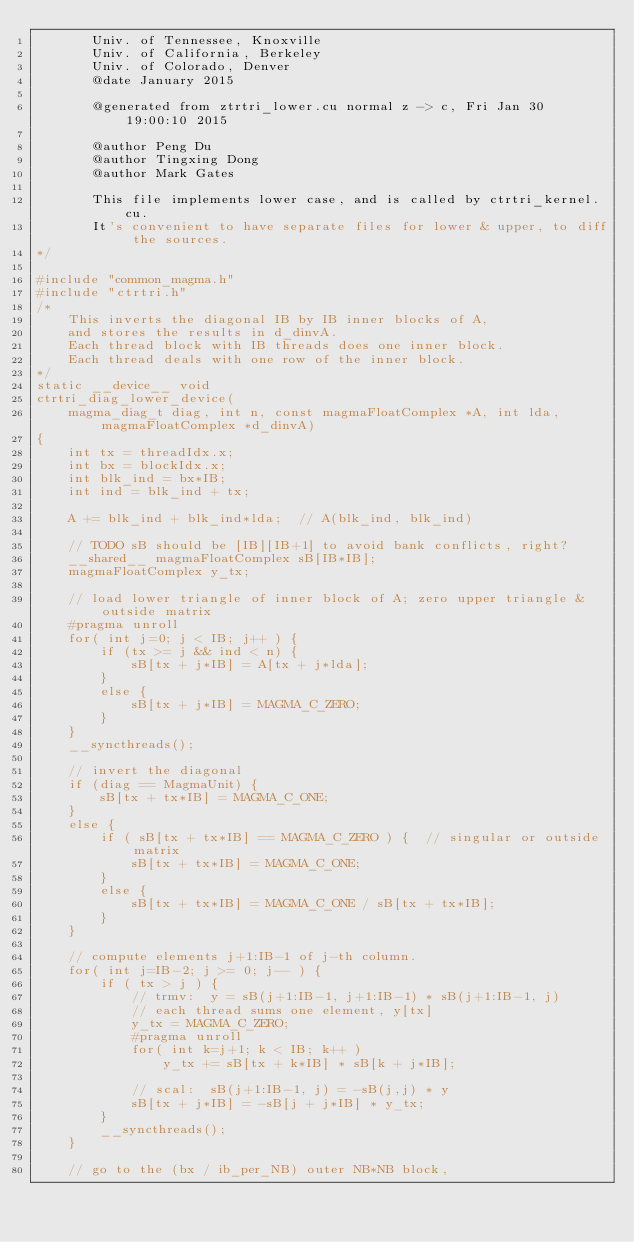Convert code to text. <code><loc_0><loc_0><loc_500><loc_500><_Cuda_>       Univ. of Tennessee, Knoxville
       Univ. of California, Berkeley
       Univ. of Colorado, Denver
       @date January 2015

       @generated from ztrtri_lower.cu normal z -> c, Fri Jan 30 19:00:10 2015

       @author Peng Du
       @author Tingxing Dong
       @author Mark Gates
       
       This file implements lower case, and is called by ctrtri_kernel.cu.
       It's convenient to have separate files for lower & upper, to diff the sources.
*/

#include "common_magma.h"
#include "ctrtri.h"
/*
    This inverts the diagonal IB by IB inner blocks of A,
    and stores the results in d_dinvA.
    Each thread block with IB threads does one inner block.
    Each thread deals with one row of the inner block.
*/
static __device__ void
ctrtri_diag_lower_device(
    magma_diag_t diag, int n, const magmaFloatComplex *A, int lda, magmaFloatComplex *d_dinvA)
{
    int tx = threadIdx.x;
    int bx = blockIdx.x;
    int blk_ind = bx*IB;
    int ind = blk_ind + tx;

    A += blk_ind + blk_ind*lda;  // A(blk_ind, blk_ind)

    // TODO sB should be [IB][IB+1] to avoid bank conflicts, right?
    __shared__ magmaFloatComplex sB[IB*IB];
    magmaFloatComplex y_tx;

    // load lower triangle of inner block of A; zero upper triangle & outside matrix
    #pragma unroll
    for( int j=0; j < IB; j++ ) {
        if (tx >= j && ind < n) {
            sB[tx + j*IB] = A[tx + j*lda];
        }
        else {
            sB[tx + j*IB] = MAGMA_C_ZERO;
        }
    }
    __syncthreads();
    
    // invert the diagonal
    if (diag == MagmaUnit) {
        sB[tx + tx*IB] = MAGMA_C_ONE;
    }
    else {
        if ( sB[tx + tx*IB] == MAGMA_C_ZERO ) {  // singular or outside matrix
            sB[tx + tx*IB] = MAGMA_C_ONE;
        }
        else {
            sB[tx + tx*IB] = MAGMA_C_ONE / sB[tx + tx*IB];
        }
    }
    
    // compute elements j+1:IB-1 of j-th column.
    for( int j=IB-2; j >= 0; j-- ) {
        if ( tx > j ) {
            // trmv:  y = sB(j+1:IB-1, j+1:IB-1) * sB(j+1:IB-1, j)
            // each thread sums one element, y[tx]
            y_tx = MAGMA_C_ZERO;
            #pragma unroll
            for( int k=j+1; k < IB; k++ )
                y_tx += sB[tx + k*IB] * sB[k + j*IB];
    
            // scal:  sB(j+1:IB-1, j) = -sB(j,j) * y
            sB[tx + j*IB] = -sB[j + j*IB] * y_tx;
        }
        __syncthreads();
    }
    
    // go to the (bx / ib_per_NB) outer NB*NB block,</code> 